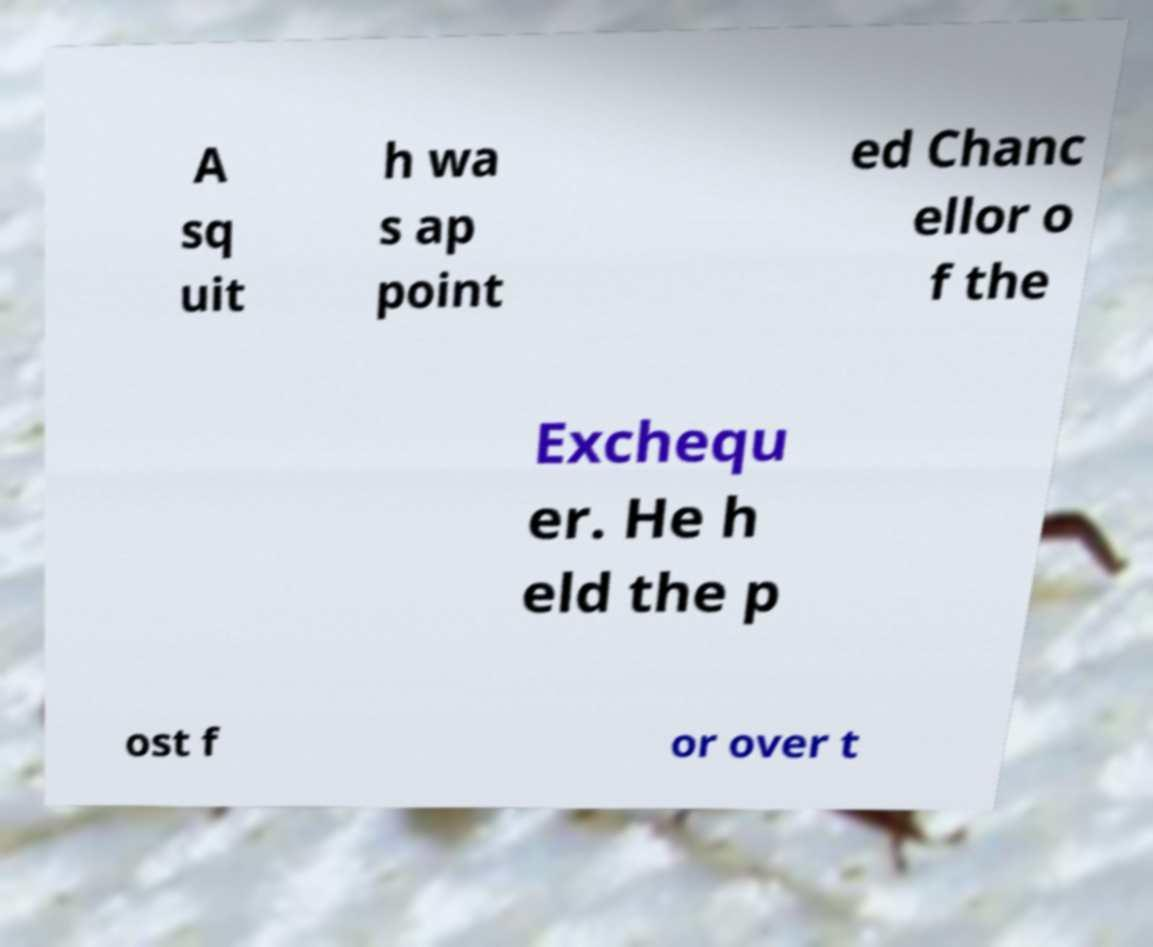Can you read and provide the text displayed in the image?This photo seems to have some interesting text. Can you extract and type it out for me? A sq uit h wa s ap point ed Chanc ellor o f the Exchequ er. He h eld the p ost f or over t 